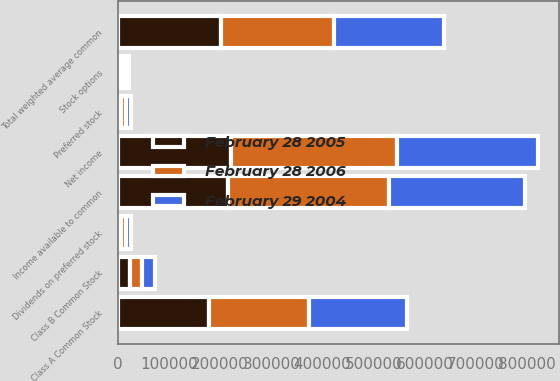Convert chart. <chart><loc_0><loc_0><loc_500><loc_500><stacked_bar_chart><ecel><fcel>Net income<fcel>Dividends on preferred stock<fcel>Income available to common<fcel>Class A Common Stock<fcel>Class B Common Stock<fcel>Total weighted average common<fcel>Stock options<fcel>Preferred stock<nl><fcel>February 28 2006<fcel>325262<fcel>9804<fcel>315458<fcel>196907<fcel>23904<fcel>220811<fcel>7913<fcel>9983<nl><fcel>February 29 2004<fcel>276464<fcel>9804<fcel>266660<fcel>191489<fcel>24043<fcel>215532<fcel>7545<fcel>9983<nl><fcel>February 28 2005<fcel>220414<fcel>5746<fcel>214668<fcel>177267<fcel>24137<fcel>201404<fcel>6628<fcel>5865<nl></chart> 